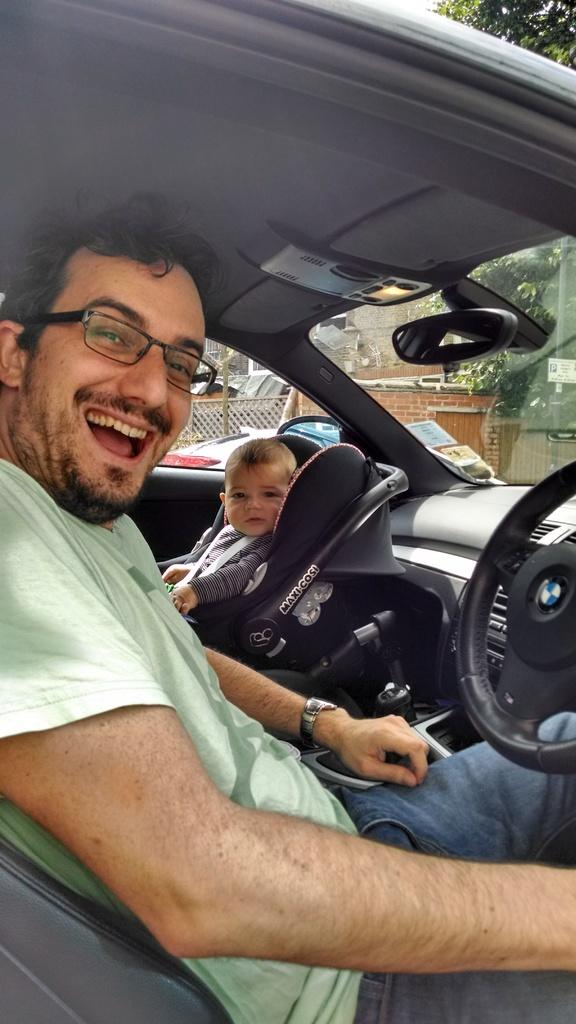What is the main subject of the image? The main subject of the image is a man. What is the man doing in the image? The man is sitting in a car. Is there anyone else present in the image? Yes, there is a baby in the image. Where is the baby located in relation to the man? The baby is beside the man in the car. What type of cave can be seen in the background of the image? There is no cave present in the image. What is the porter carrying in the image? There is no porter present in the image. What belief system is being practiced by the people in the image? There is no indication of any belief system being practiced in the image. 